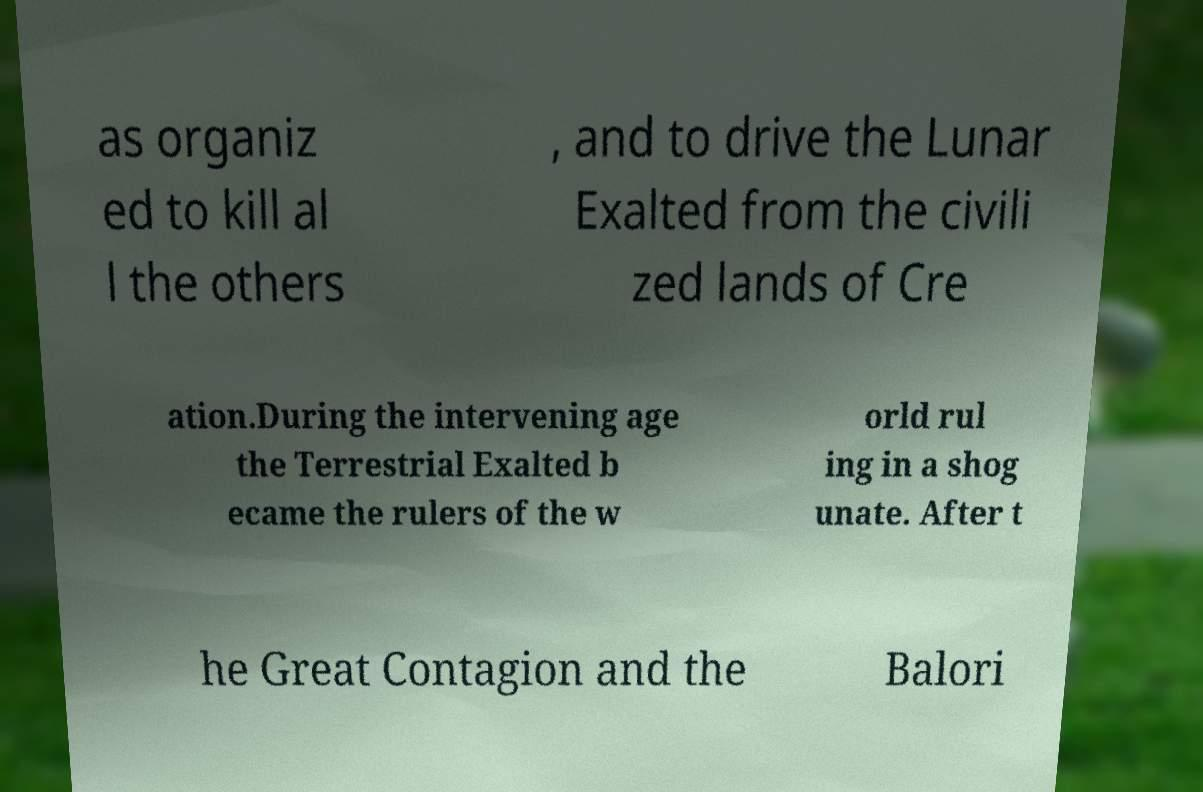What messages or text are displayed in this image? I need them in a readable, typed format. as organiz ed to kill al l the others , and to drive the Lunar Exalted from the civili zed lands of Cre ation.During the intervening age the Terrestrial Exalted b ecame the rulers of the w orld rul ing in a shog unate. After t he Great Contagion and the Balori 